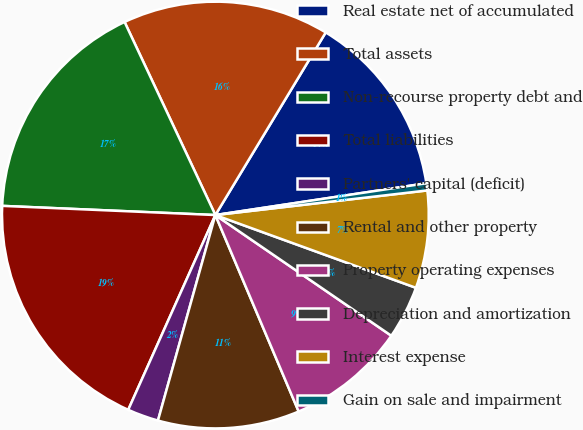<chart> <loc_0><loc_0><loc_500><loc_500><pie_chart><fcel>Real estate net of accumulated<fcel>Total assets<fcel>Non-recourse property debt and<fcel>Total liabilities<fcel>Partners' capital (deficit)<fcel>Rental and other property<fcel>Property operating expenses<fcel>Depreciation and amortization<fcel>Interest expense<fcel>Gain on sale and impairment<nl><fcel>13.97%<fcel>15.65%<fcel>17.32%<fcel>18.99%<fcel>2.36%<fcel>10.72%<fcel>9.05%<fcel>4.03%<fcel>7.38%<fcel>0.54%<nl></chart> 